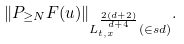Convert formula to latex. <formula><loc_0><loc_0><loc_500><loc_500>\| P _ { \geq N } F ( u ) \| _ { L _ { t , x } ^ { \frac { 2 ( d + 2 ) } { d + 4 } } ( \in s d ) } .</formula> 